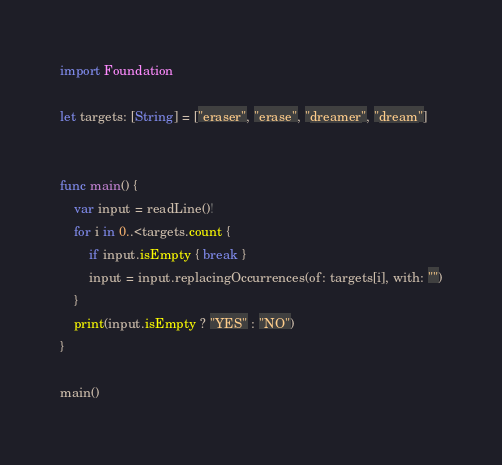<code> <loc_0><loc_0><loc_500><loc_500><_Swift_>import Foundation

let targets: [String] = ["eraser", "erase", "dreamer", "dream"]


func main() {
	var input = readLine()!
	for i in 0..<targets.count {
		if input.isEmpty { break }
		input = input.replacingOccurrences(of: targets[i], with: "")
	}
	print(input.isEmpty ? "YES" : "NO")
}

main()</code> 